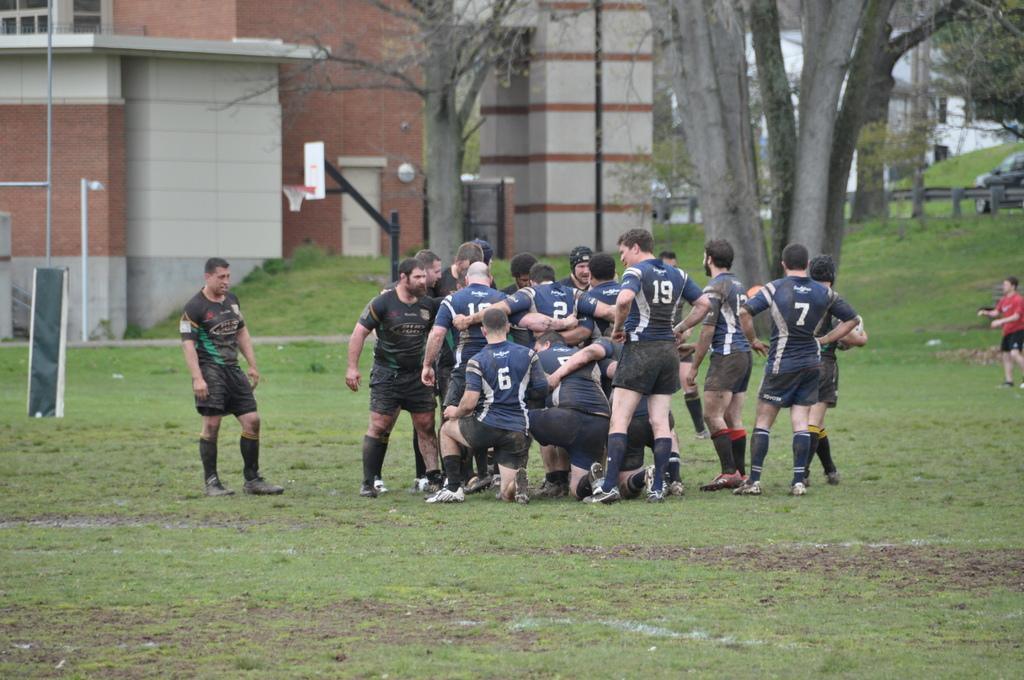What is the main subject of the image? There is a group of people standing on the ground. What can be seen in the background of the image? There is a group of trees and buildings in the background. Is there any transportation visible in the image? Yes, a vehicle is visible in the background. What type of gold can be seen in the image? There is no gold present in the image. What is the purpose of the yam in the image? There is no yam present in the image. 